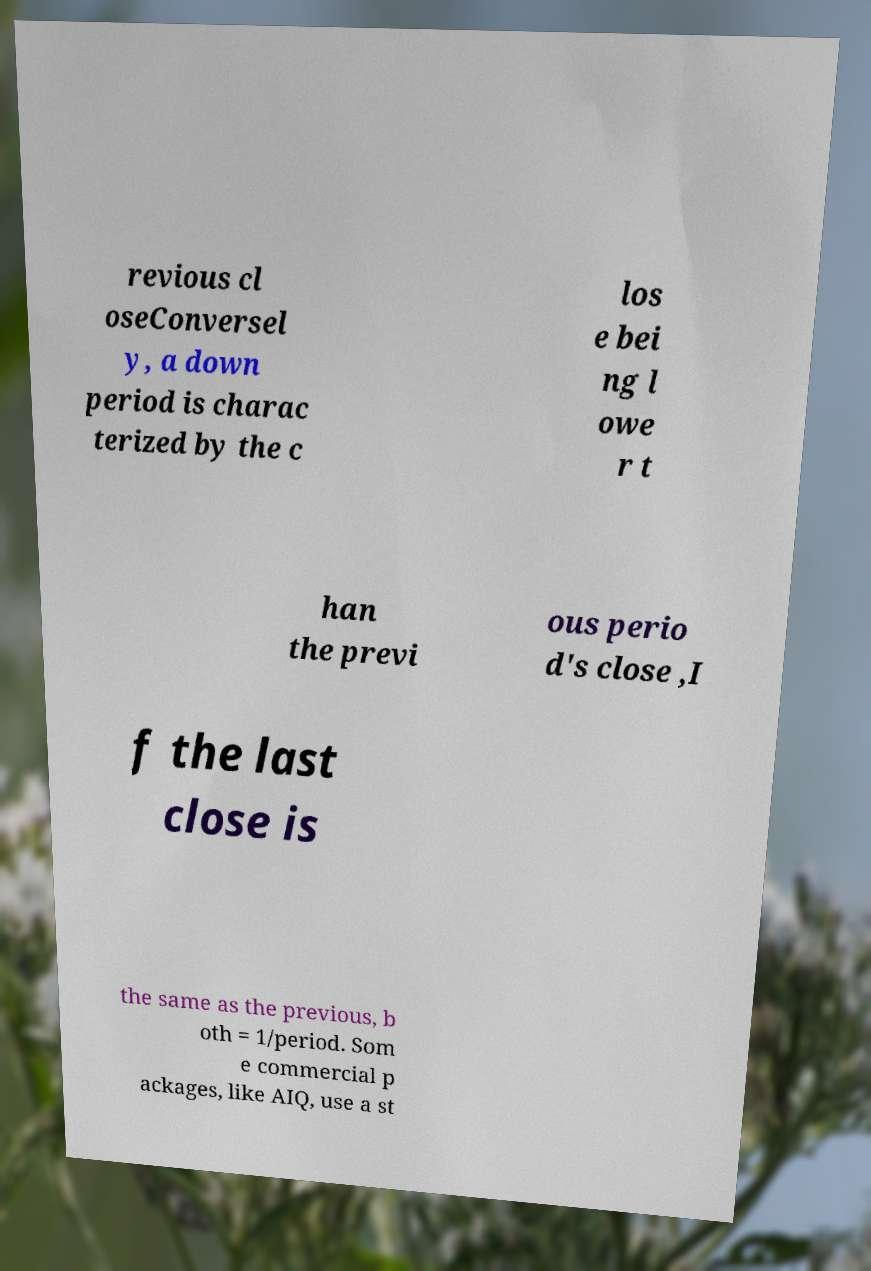There's text embedded in this image that I need extracted. Can you transcribe it verbatim? revious cl oseConversel y, a down period is charac terized by the c los e bei ng l owe r t han the previ ous perio d's close ,I f the last close is the same as the previous, b oth = 1/period. Som e commercial p ackages, like AIQ, use a st 